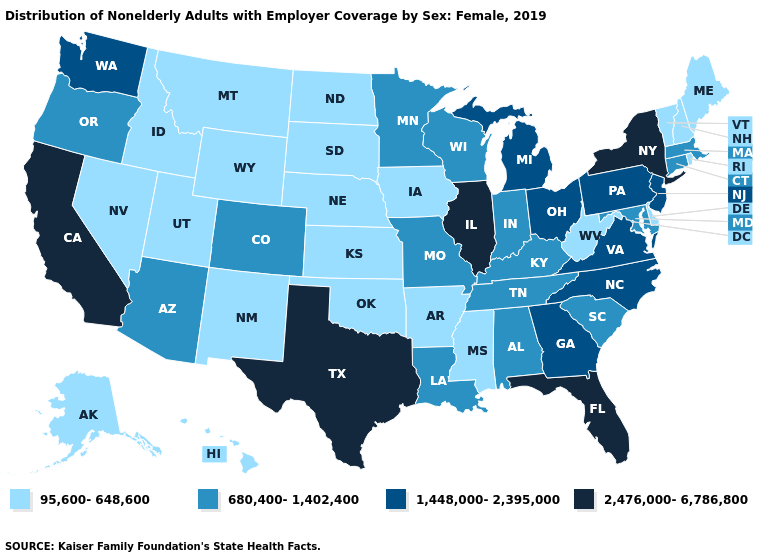Name the states that have a value in the range 1,448,000-2,395,000?
Quick response, please. Georgia, Michigan, New Jersey, North Carolina, Ohio, Pennsylvania, Virginia, Washington. Is the legend a continuous bar?
Quick response, please. No. Name the states that have a value in the range 2,476,000-6,786,800?
Keep it brief. California, Florida, Illinois, New York, Texas. What is the highest value in the MidWest ?
Keep it brief. 2,476,000-6,786,800. What is the highest value in states that border North Carolina?
Give a very brief answer. 1,448,000-2,395,000. Which states hav the highest value in the MidWest?
Quick response, please. Illinois. Does Arkansas have the lowest value in the USA?
Short answer required. Yes. What is the value of Arizona?
Write a very short answer. 680,400-1,402,400. Among the states that border Minnesota , does Iowa have the highest value?
Quick response, please. No. What is the value of Maine?
Answer briefly. 95,600-648,600. Does the map have missing data?
Keep it brief. No. What is the value of Vermont?
Concise answer only. 95,600-648,600. What is the value of South Dakota?
Write a very short answer. 95,600-648,600. What is the highest value in the Northeast ?
Keep it brief. 2,476,000-6,786,800. What is the value of Florida?
Write a very short answer. 2,476,000-6,786,800. 